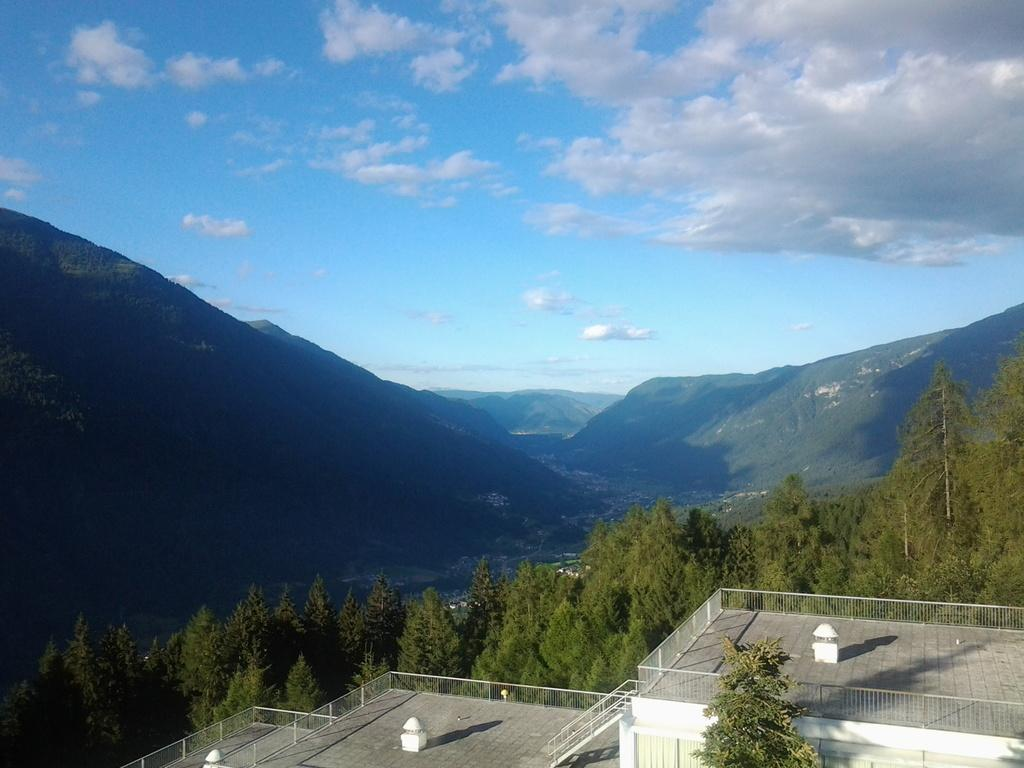What type of structure is visible in the image? There is a building in the image. What other natural elements can be seen in the image? There are trees and mountains visible in the image. What is visible in the background of the image? In the background, there are clouds and the sky. Can you describe any shadows present in the image? Yes, there is a shadow present in the image. What type of watch is the vase wearing in the image? There is no vase or watch present in the image. What type of border surrounds the mountains in the image? There is no border surrounding the mountains in the image; they are part of the natural landscape. 